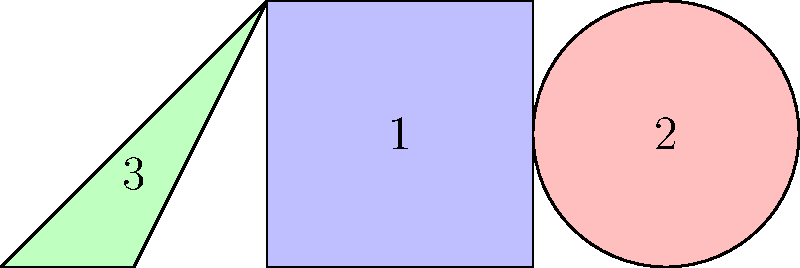Look at the picture carefully. Which shape is labeled with the number 2? Let's examine each shape in the picture:

1. Shape 1 is a blue square. It has four equal sides and four right angles.
2. Shape 2 is a red circle. It is a perfectly round shape with no corners or edges.
3. Shape 3 is a green triangle. It has three sides and three angles.

The question asks about the shape labeled with the number 2. Looking at the image, we can see that the number 2 is placed inside the red circular shape.
Answer: Circle 